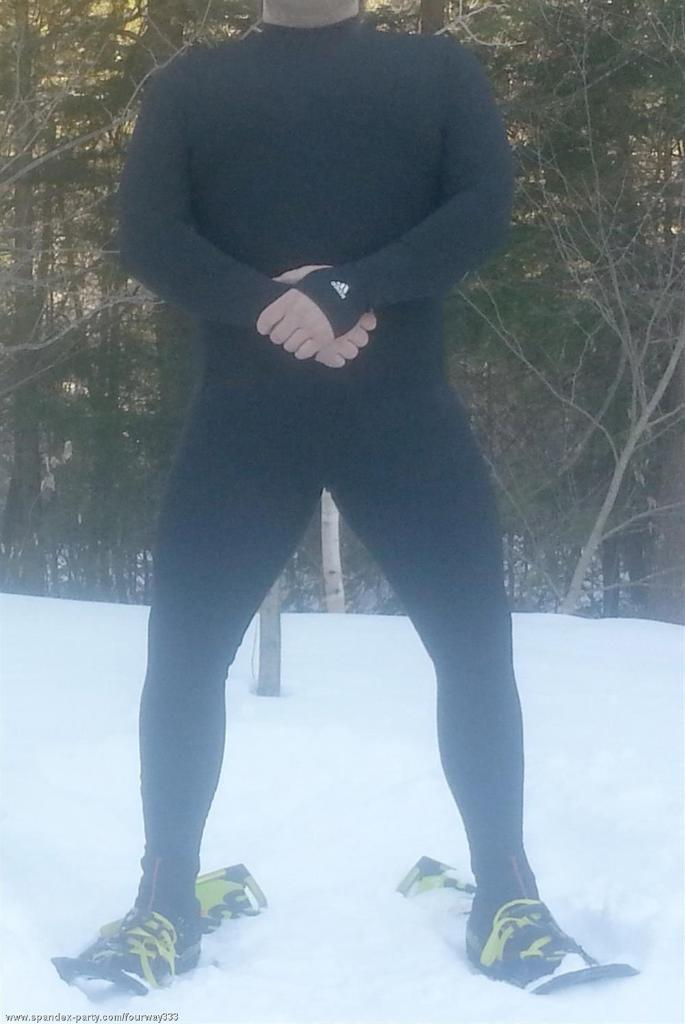What is the main subject of the image? There is a person standing in the image. What is the person standing on? The person appears to be standing on clouds, which are often associated with the sky. What type of weather is depicted in the image? There is snow visible in the image. What can be seen in the background of the image? There are trees in the background of the image. Where is the text located in the image? The text is in the bottom left side of the image. What type of blood is visible on the bottle in the image? There is no bottle or blood present in the image. How is the knife being used by the person in the image? There is no knife present in the image. 